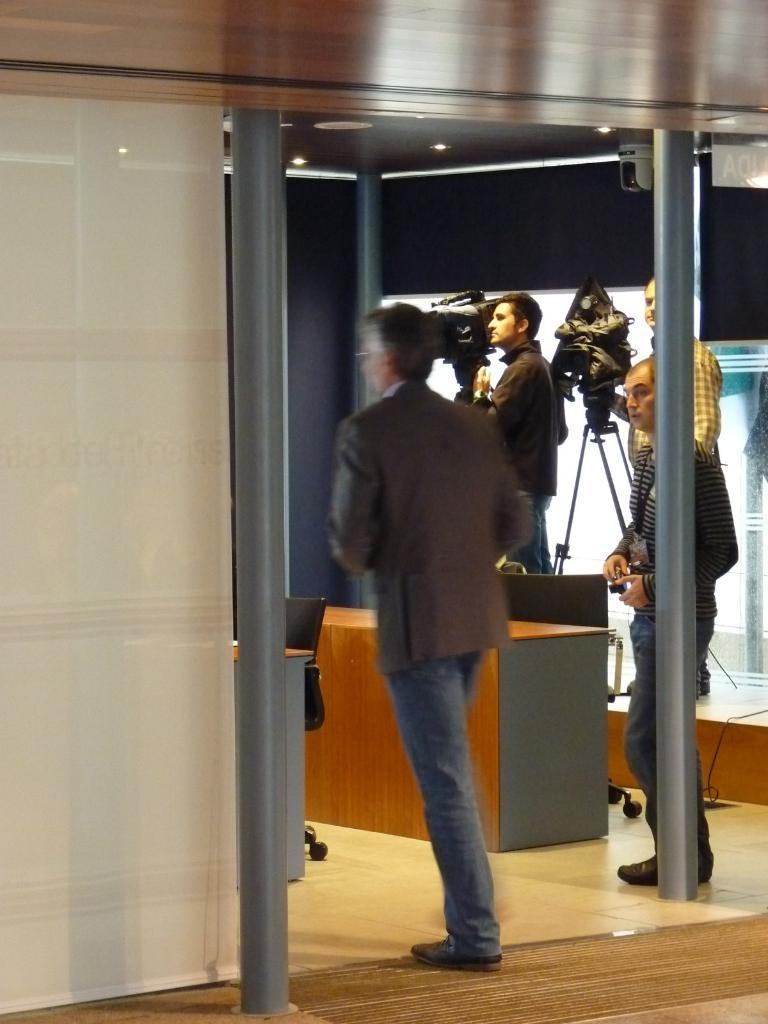What is the man in the image doing? The man is walking in the image. What can be seen in the background of the image? There are three people standing in the background of the image. What is visible at the top of the image? The ceiling is visible at the top of the image. What type of furniture is present in the image? There is a chair and a desk in the image. What color is the paint on the daughter's room in the image? There is no mention of a daughter or a room in the image, so we cannot determine the color of any paint. 